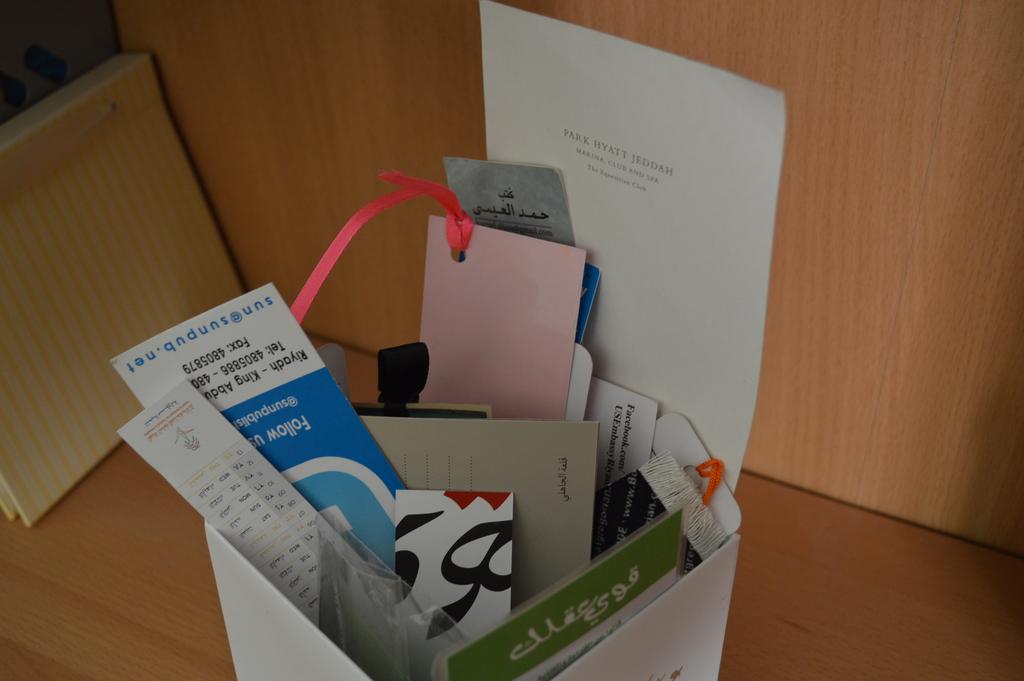What is the website shown on the blue card?
Provide a short and direct response. Sun@sunpub.net. What name is on the paper sticking out the back?
Your response must be concise. Park hyatt jeddah. 